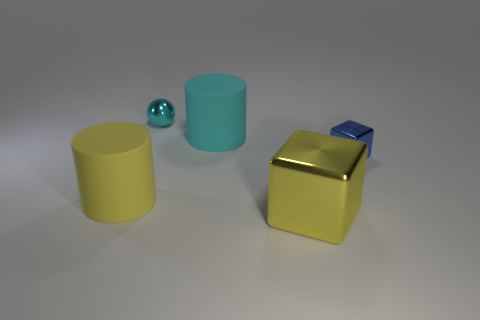Add 3 matte cylinders. How many objects exist? 8 Subtract all cylinders. How many objects are left? 3 Subtract 1 yellow cylinders. How many objects are left? 4 Subtract all big brown rubber spheres. Subtract all small objects. How many objects are left? 3 Add 2 large cyan cylinders. How many large cyan cylinders are left? 3 Add 3 cyan rubber things. How many cyan rubber things exist? 4 